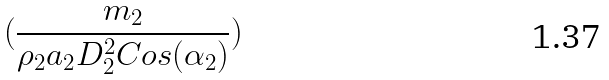<formula> <loc_0><loc_0><loc_500><loc_500>( \frac { m _ { 2 } } { \rho _ { 2 } a _ { 2 } D _ { 2 } ^ { 2 } C o s ( \alpha _ { 2 } ) } )</formula> 